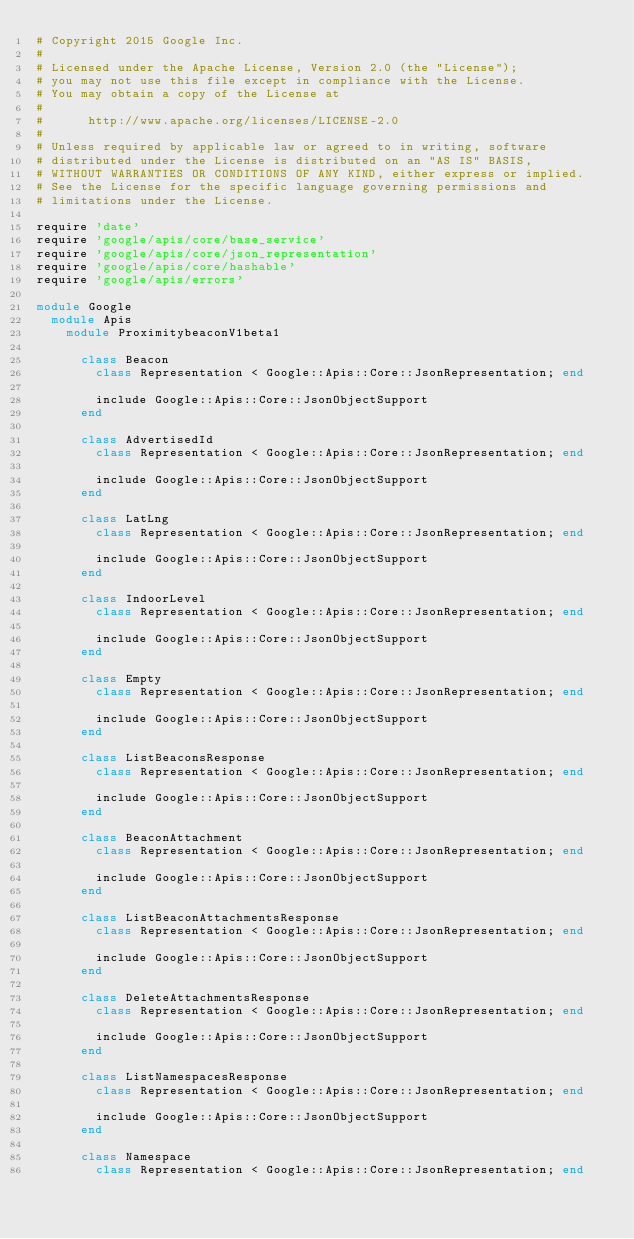Convert code to text. <code><loc_0><loc_0><loc_500><loc_500><_Ruby_># Copyright 2015 Google Inc.
#
# Licensed under the Apache License, Version 2.0 (the "License");
# you may not use this file except in compliance with the License.
# You may obtain a copy of the License at
#
#      http://www.apache.org/licenses/LICENSE-2.0
#
# Unless required by applicable law or agreed to in writing, software
# distributed under the License is distributed on an "AS IS" BASIS,
# WITHOUT WARRANTIES OR CONDITIONS OF ANY KIND, either express or implied.
# See the License for the specific language governing permissions and
# limitations under the License.

require 'date'
require 'google/apis/core/base_service'
require 'google/apis/core/json_representation'
require 'google/apis/core/hashable'
require 'google/apis/errors'

module Google
  module Apis
    module ProximitybeaconV1beta1
      
      class Beacon
        class Representation < Google::Apis::Core::JsonRepresentation; end
      
        include Google::Apis::Core::JsonObjectSupport
      end
      
      class AdvertisedId
        class Representation < Google::Apis::Core::JsonRepresentation; end
      
        include Google::Apis::Core::JsonObjectSupport
      end
      
      class LatLng
        class Representation < Google::Apis::Core::JsonRepresentation; end
      
        include Google::Apis::Core::JsonObjectSupport
      end
      
      class IndoorLevel
        class Representation < Google::Apis::Core::JsonRepresentation; end
      
        include Google::Apis::Core::JsonObjectSupport
      end
      
      class Empty
        class Representation < Google::Apis::Core::JsonRepresentation; end
      
        include Google::Apis::Core::JsonObjectSupport
      end
      
      class ListBeaconsResponse
        class Representation < Google::Apis::Core::JsonRepresentation; end
      
        include Google::Apis::Core::JsonObjectSupport
      end
      
      class BeaconAttachment
        class Representation < Google::Apis::Core::JsonRepresentation; end
      
        include Google::Apis::Core::JsonObjectSupport
      end
      
      class ListBeaconAttachmentsResponse
        class Representation < Google::Apis::Core::JsonRepresentation; end
      
        include Google::Apis::Core::JsonObjectSupport
      end
      
      class DeleteAttachmentsResponse
        class Representation < Google::Apis::Core::JsonRepresentation; end
      
        include Google::Apis::Core::JsonObjectSupport
      end
      
      class ListNamespacesResponse
        class Representation < Google::Apis::Core::JsonRepresentation; end
      
        include Google::Apis::Core::JsonObjectSupport
      end
      
      class Namespace
        class Representation < Google::Apis::Core::JsonRepresentation; end
      </code> 